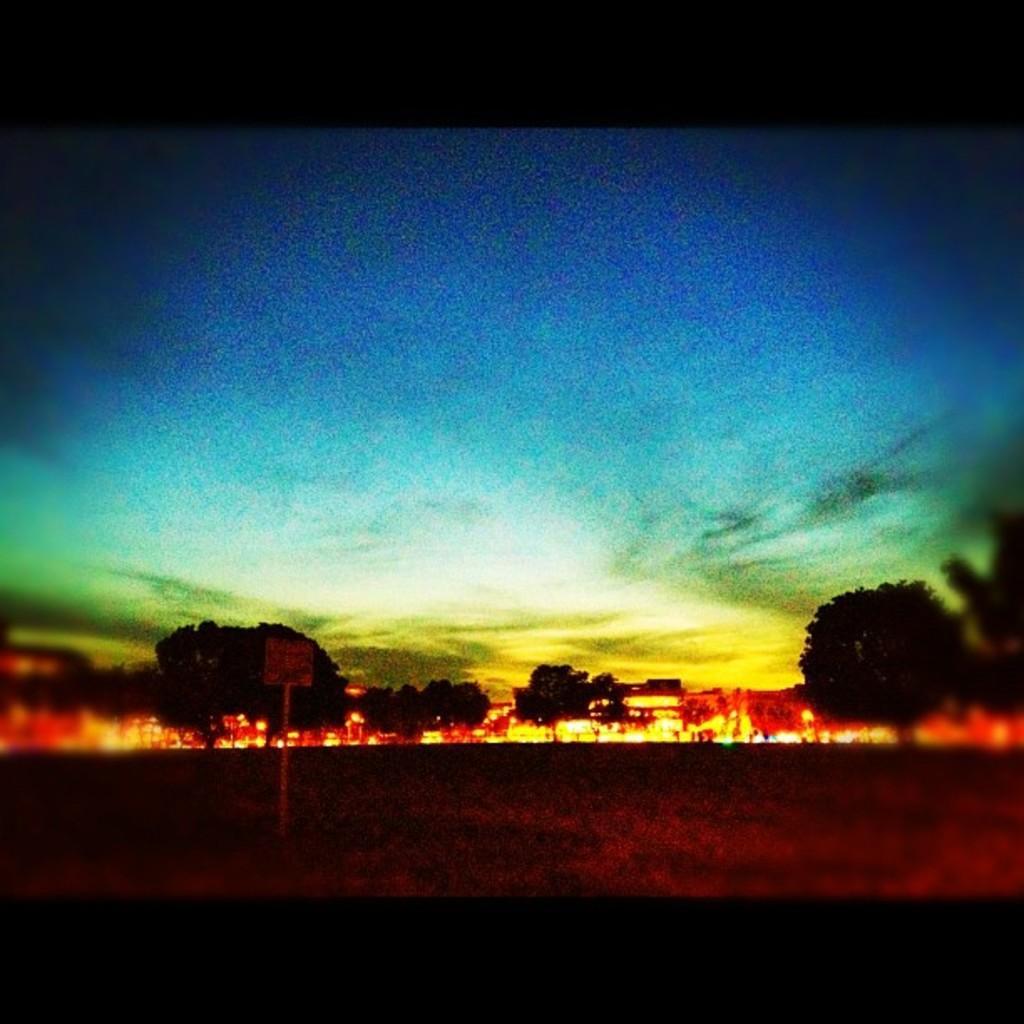Could you give a brief overview of what you see in this image? This image is taken outdoors. This is an edited image. In the background there are a few trees. At the top of the image there is a sky with clouds. 